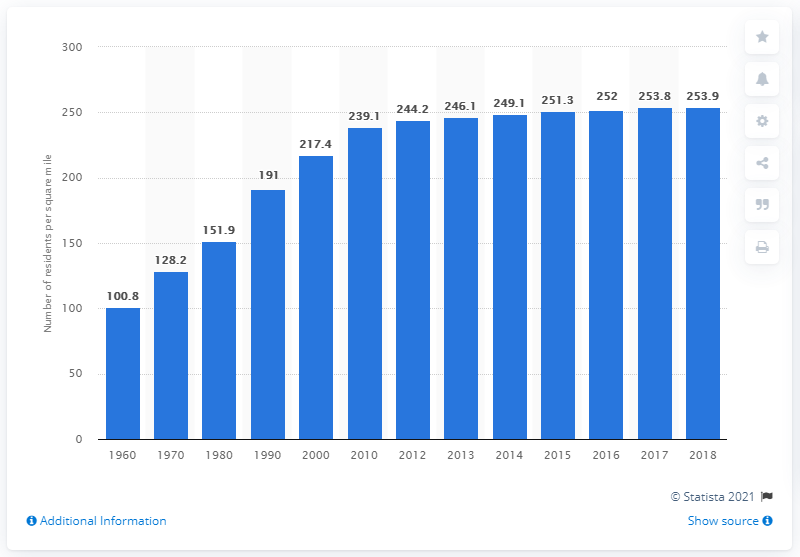Specify some key components in this picture. The population density of California in 2018 was 253.9 people per square kilometer. 